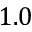Convert formula to latex. <formula><loc_0><loc_0><loc_500><loc_500>1 . 0</formula> 